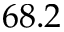Convert formula to latex. <formula><loc_0><loc_0><loc_500><loc_500>6 8 . 2</formula> 